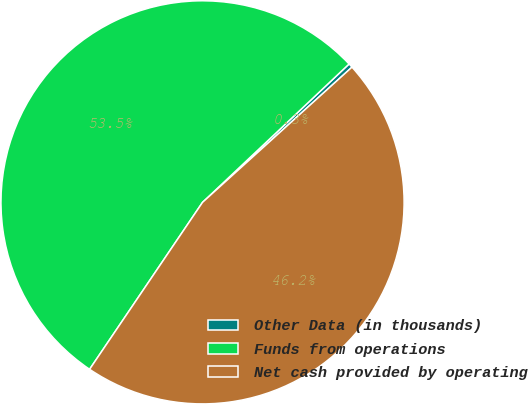Convert chart. <chart><loc_0><loc_0><loc_500><loc_500><pie_chart><fcel>Other Data (in thousands)<fcel>Funds from operations<fcel>Net cash provided by operating<nl><fcel>0.34%<fcel>53.49%<fcel>46.17%<nl></chart> 